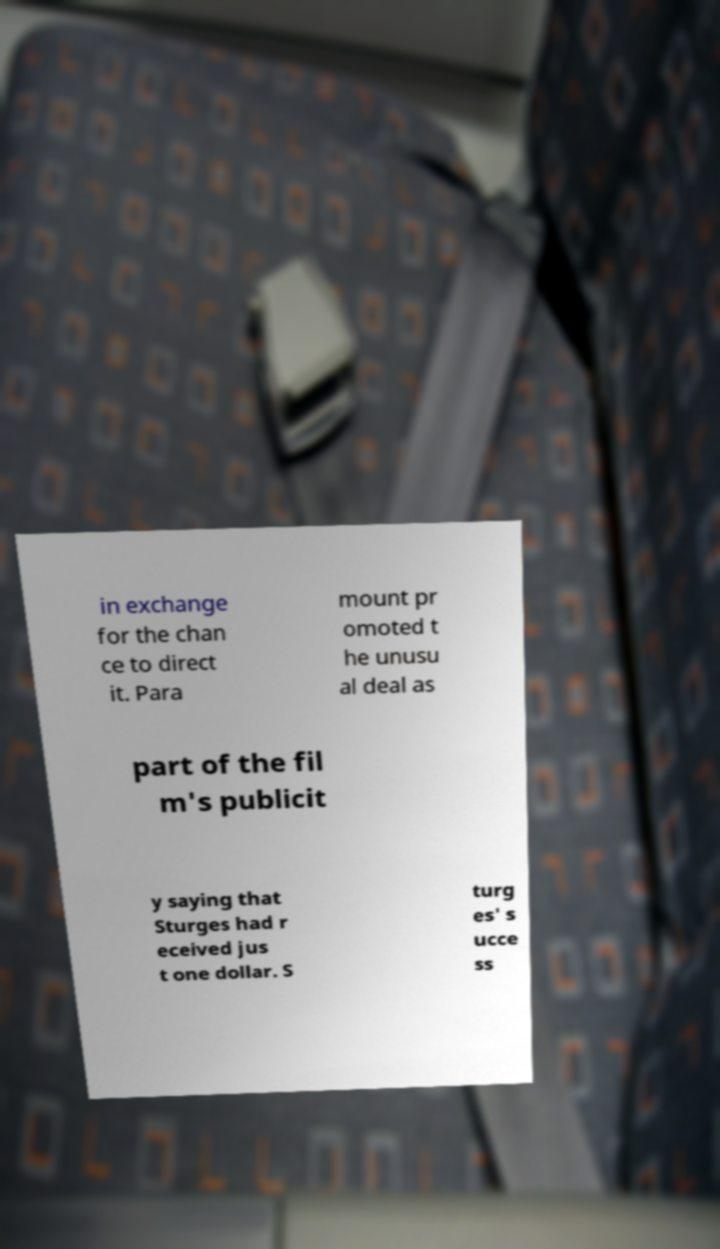Can you accurately transcribe the text from the provided image for me? in exchange for the chan ce to direct it. Para mount pr omoted t he unusu al deal as part of the fil m's publicit y saying that Sturges had r eceived jus t one dollar. S turg es' s ucce ss 